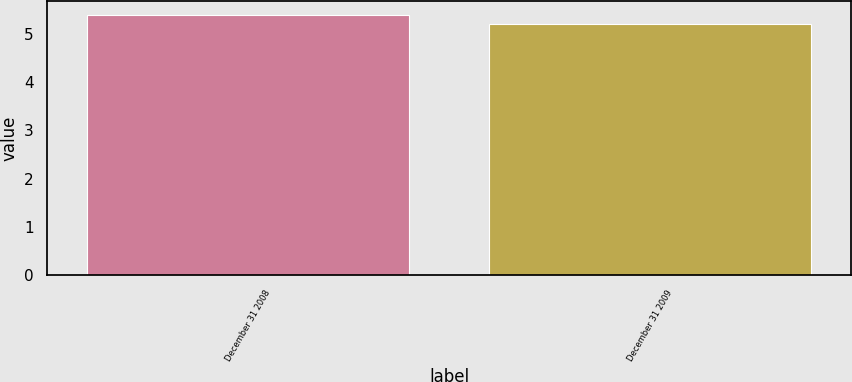Convert chart to OTSL. <chart><loc_0><loc_0><loc_500><loc_500><bar_chart><fcel>December 31 2008<fcel>December 31 2009<nl><fcel>5.4<fcel>5.2<nl></chart> 